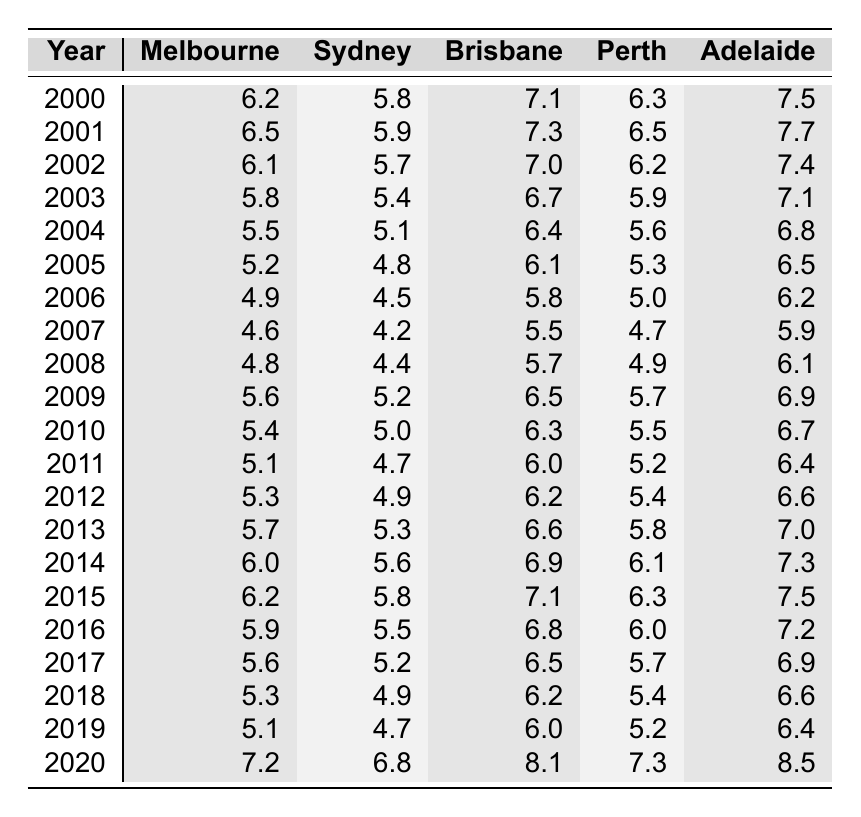What was the unemployment rate in Sydney in 2005? Looking at the table, I can see the column for Sydney and locate the row for the year 2005, where the unemployment rate is 4.8%.
Answer: 4.8% What city had the highest unemployment rate in 2020? Checking the 2020 row across all cities, I see that Adelaide has the highest unemployment rate at 8.5%.
Answer: Adelaide What was the average unemployment rate in Brisbane from 2000 to 2010? I will sum the unemployment rates for Brisbane from the years 2000 to 2010: (7.1 + 7.3 + 7.0 + 6.7 + 6.4 + 6.1 + 5.8 + 5.5 + 5.7 + 6.3) = 62.0. There are 11 data points, so the average is 62.0 / 11 = 5.64%.
Answer: 5.64% Did the unemployment rate in Melbourne increase from 2019 to 2020? Comparing the values for Melbourne in 2019 (5.1%) and 2020 (7.2%), I see that the rate did increase.
Answer: Yes What was the trend of unemployment rates in Perth from 2000 to 2010? I will review the data for Perth from 2000 to 2010: it decreased from 6.3% in 2000 down to 5.5% in 2010 (6.3% → 5.9% → 5.6% → 5.3% → 5.0% → 5.2%). Therefore, the trend was generally downward.
Answer: Downward Which city had the lowest unemployment rate in 2008? Looking at the 2008 data across all cities, I see that Melbourne had the lowest rate at 4.8%.
Answer: Melbourne How does the average unemployment rate of Adelaide compare to Sydney over the entire dataset? Summing the rates for Adelaide (7.5 + 7.7 + 7.4 + 7.1 + 6.8 + 6.5 + 6.2 + 5.9 + 6.1 + 6.7 + 6.4 + 6.6 + 7.0 + 7.3 + 7.5 + 7.2 + 6.9 + 6.6 + 6.4 + 8.5), I get 132.8 over 21 years gives an average of 6.64%. For Sydney, (5.8 + 5.9 + 5.7 + 5.4 + 5.1 + 4.8 + 4.5 + 4.2 + 4.4 + 5.2 + 5.0 + 4.7 + 4.9 + 5.3 + 5.6 + 5.8 + 5.5 + 5.2 + 4.9 + 4.7 + 6.8), summing to 110.5 gives an average of 5.25%. Since 6.64% > 5.25%, Adelaide's average is higher.
Answer: Adelaide's average is higher What was the difference in the unemployment rate between Brisbane and Adelaide in 2015? From the table, the unemployment rate for Brisbane in 2015 is 7.1% and for Adelaide, it is 7.5%. The difference is 7.5% - 7.1% = 0.4%.
Answer: 0.4% Which city showed the most improvement in unemployment rates from 2009 to 2010? Observing the rates, Brisbane fell from 6.5% in 2009 to 6.3% in 2010 (decrease of 0.2%), Sydney reduced from 5.2% to 5.0% (decrease of 0.2%), Melbourne decreased from 5.6% to 5.4% (decrease of 0.2%), and Perth decreased from 5.7% to 5.5% (decrease of 0.2%) as well. However, all four cities improved equally.
Answer: All improved equally 